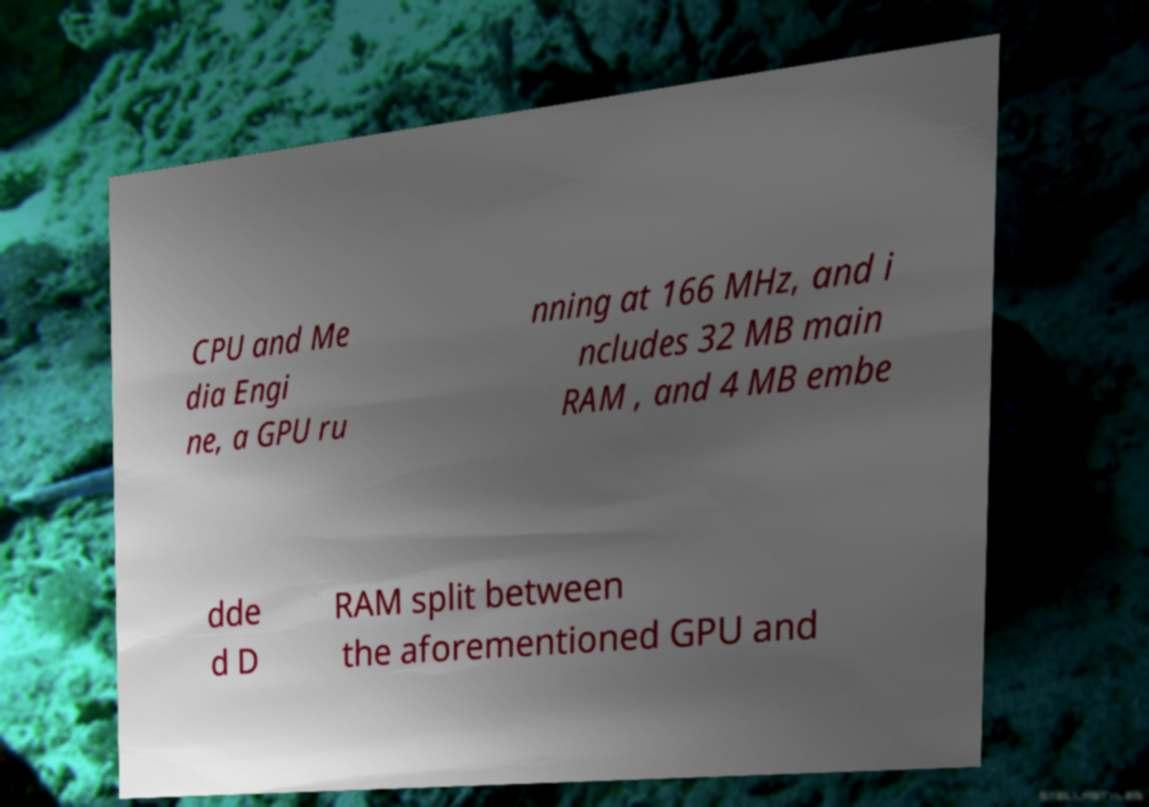Could you extract and type out the text from this image? CPU and Me dia Engi ne, a GPU ru nning at 166 MHz, and i ncludes 32 MB main RAM , and 4 MB embe dde d D RAM split between the aforementioned GPU and 